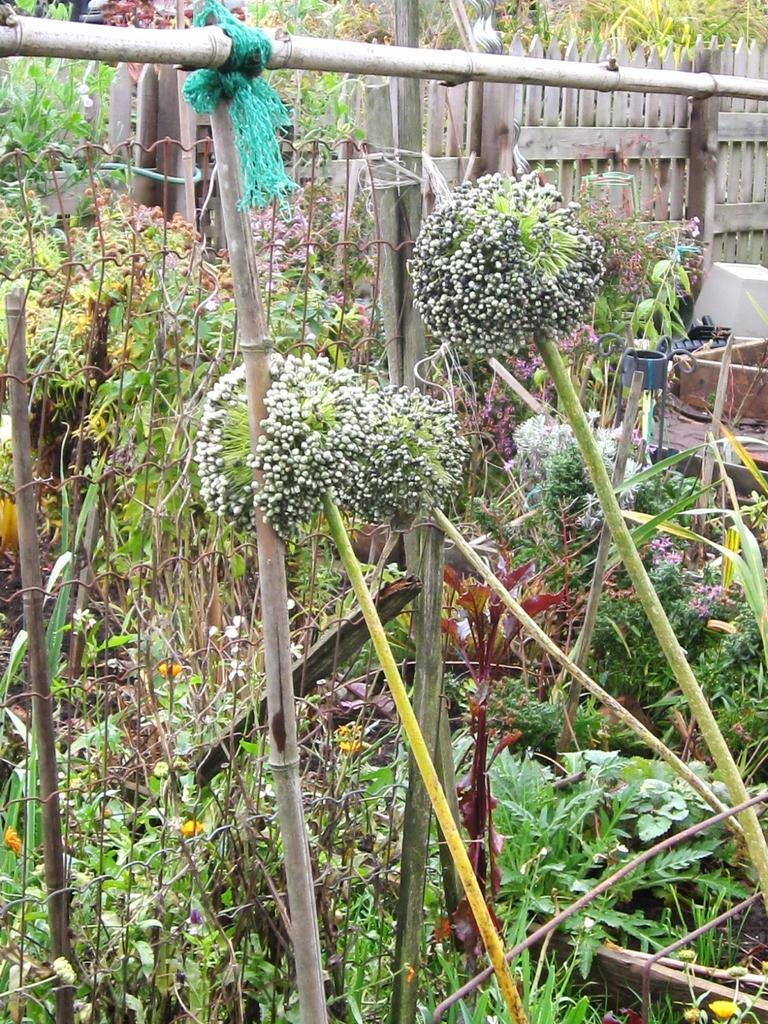What types of living organisms can be seen in the image? Plants and flowers are visible in the image. Can you describe the wooden structure in the background of the image? There is a wooden fence in the background of the image. What is located behind the wooden fence in the background of the image? There are plants behind the wooden fence in the background of the image. How does the steam escape from the land in the image? There is no steam or land present in the image; it features plants, flowers, and a wooden fence. 